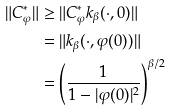Convert formula to latex. <formula><loc_0><loc_0><loc_500><loc_500>\| C _ { \varphi } ^ { * } \| & \geq \| C _ { \varphi } ^ { * } k _ { \beta } ( \cdot , 0 ) \| \\ & = \| k _ { \beta } ( \cdot , \varphi ( 0 ) ) \| \\ & = \left ( \frac { 1 } { 1 - | \varphi ( 0 ) | ^ { 2 } } \right ) ^ { \beta / 2 }</formula> 